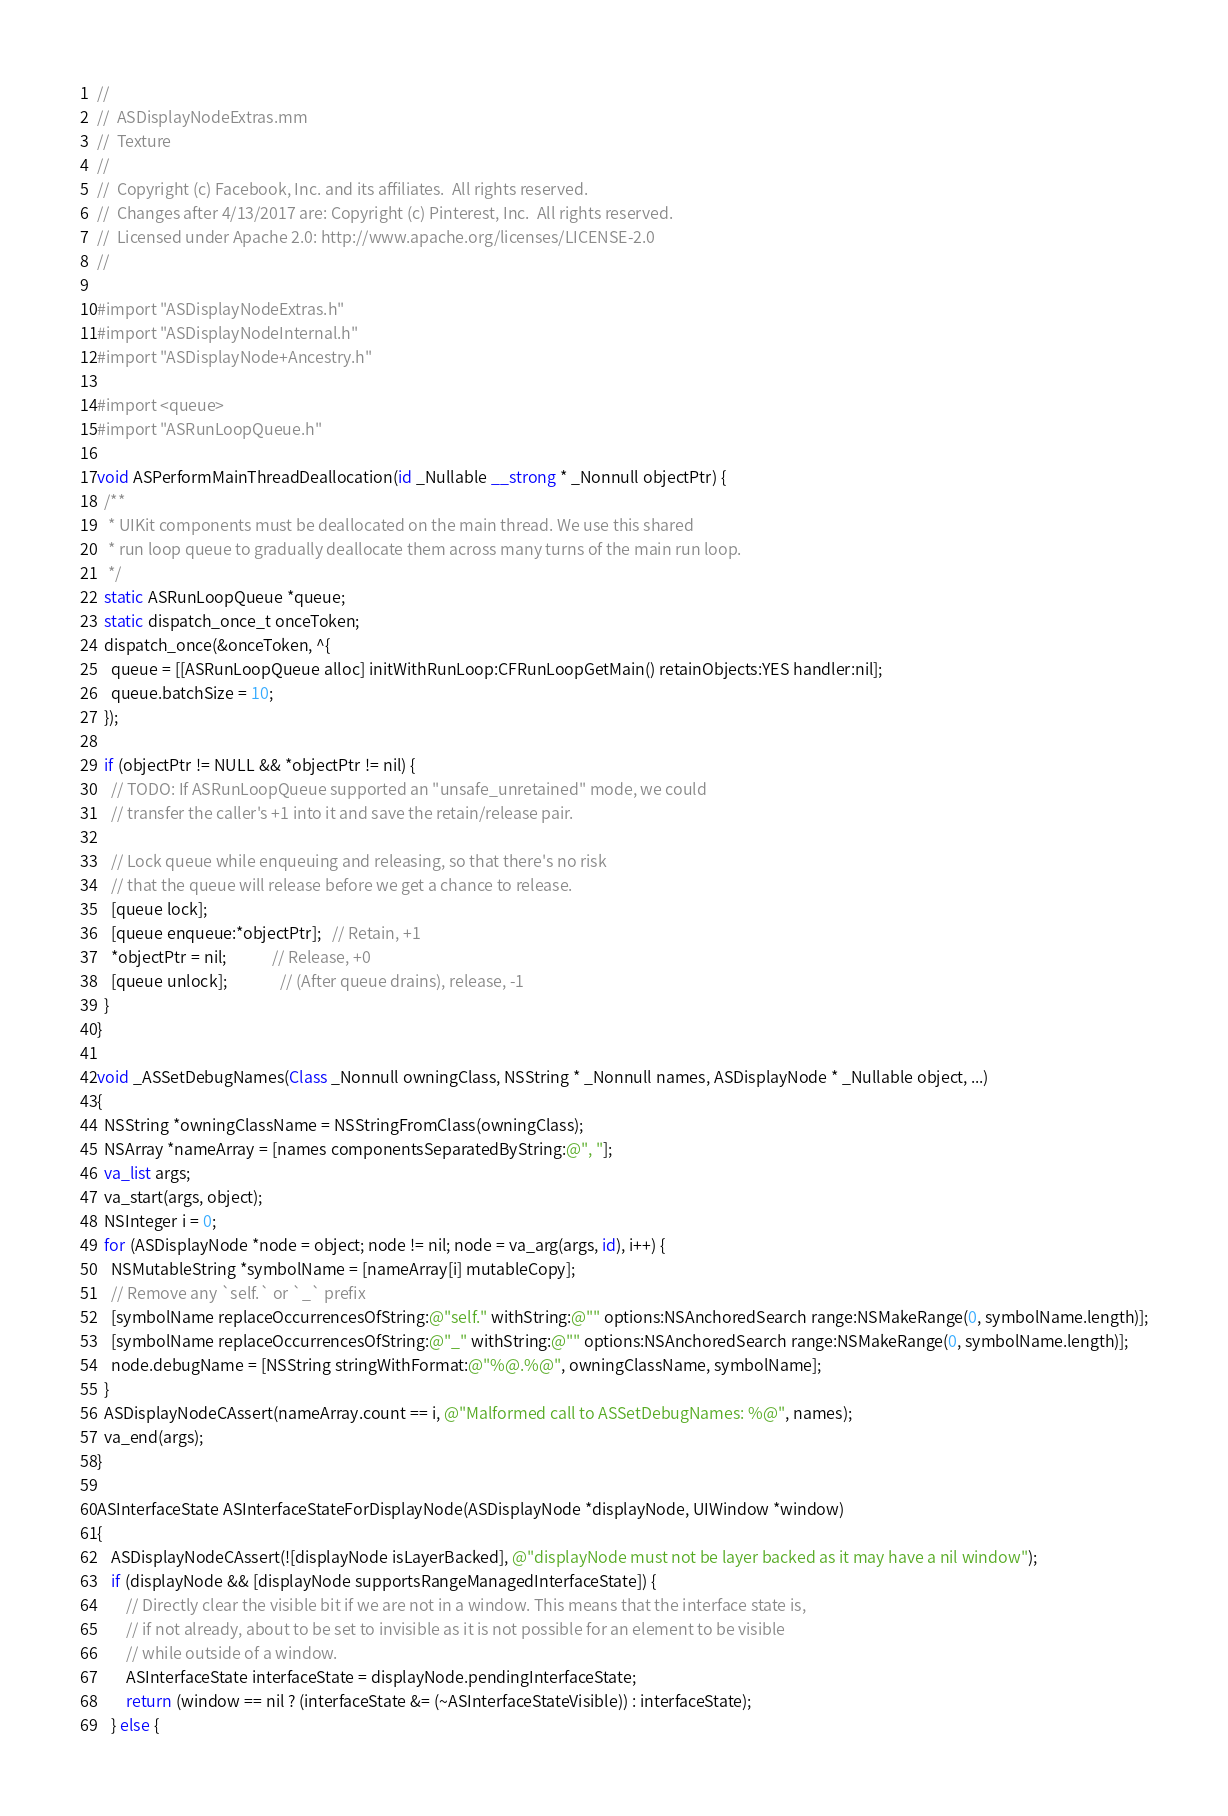Convert code to text. <code><loc_0><loc_0><loc_500><loc_500><_ObjectiveC_>//
//  ASDisplayNodeExtras.mm
//  Texture
//
//  Copyright (c) Facebook, Inc. and its affiliates.  All rights reserved.
//  Changes after 4/13/2017 are: Copyright (c) Pinterest, Inc.  All rights reserved.
//  Licensed under Apache 2.0: http://www.apache.org/licenses/LICENSE-2.0
//

#import "ASDisplayNodeExtras.h"
#import "ASDisplayNodeInternal.h"
#import "ASDisplayNode+Ancestry.h"

#import <queue>
#import "ASRunLoopQueue.h"

void ASPerformMainThreadDeallocation(id _Nullable __strong * _Nonnull objectPtr) {
  /**
   * UIKit components must be deallocated on the main thread. We use this shared
   * run loop queue to gradually deallocate them across many turns of the main run loop.
   */
  static ASRunLoopQueue *queue;
  static dispatch_once_t onceToken;
  dispatch_once(&onceToken, ^{
    queue = [[ASRunLoopQueue alloc] initWithRunLoop:CFRunLoopGetMain() retainObjects:YES handler:nil];
    queue.batchSize = 10;
  });

  if (objectPtr != NULL && *objectPtr != nil) {
    // TODO: If ASRunLoopQueue supported an "unsafe_unretained" mode, we could
    // transfer the caller's +1 into it and save the retain/release pair.
    
    // Lock queue while enqueuing and releasing, so that there's no risk
    // that the queue will release before we get a chance to release.
    [queue lock];
    [queue enqueue:*objectPtr];   // Retain, +1
    *objectPtr = nil;             // Release, +0
    [queue unlock];               // (After queue drains), release, -1
  }
}

void _ASSetDebugNames(Class _Nonnull owningClass, NSString * _Nonnull names, ASDisplayNode * _Nullable object, ...)
{
  NSString *owningClassName = NSStringFromClass(owningClass);
  NSArray *nameArray = [names componentsSeparatedByString:@", "];
  va_list args;
  va_start(args, object);
  NSInteger i = 0;
  for (ASDisplayNode *node = object; node != nil; node = va_arg(args, id), i++) {
    NSMutableString *symbolName = [nameArray[i] mutableCopy];
    // Remove any `self.` or `_` prefix
    [symbolName replaceOccurrencesOfString:@"self." withString:@"" options:NSAnchoredSearch range:NSMakeRange(0, symbolName.length)];
    [symbolName replaceOccurrencesOfString:@"_" withString:@"" options:NSAnchoredSearch range:NSMakeRange(0, symbolName.length)];
    node.debugName = [NSString stringWithFormat:@"%@.%@", owningClassName, symbolName];
  }
  ASDisplayNodeCAssert(nameArray.count == i, @"Malformed call to ASSetDebugNames: %@", names);
  va_end(args);
}

ASInterfaceState ASInterfaceStateForDisplayNode(ASDisplayNode *displayNode, UIWindow *window)
{
    ASDisplayNodeCAssert(![displayNode isLayerBacked], @"displayNode must not be layer backed as it may have a nil window");
    if (displayNode && [displayNode supportsRangeManagedInterfaceState]) {
        // Directly clear the visible bit if we are not in a window. This means that the interface state is,
        // if not already, about to be set to invisible as it is not possible for an element to be visible
        // while outside of a window.
        ASInterfaceState interfaceState = displayNode.pendingInterfaceState;
        return (window == nil ? (interfaceState &= (~ASInterfaceStateVisible)) : interfaceState);
    } else {</code> 